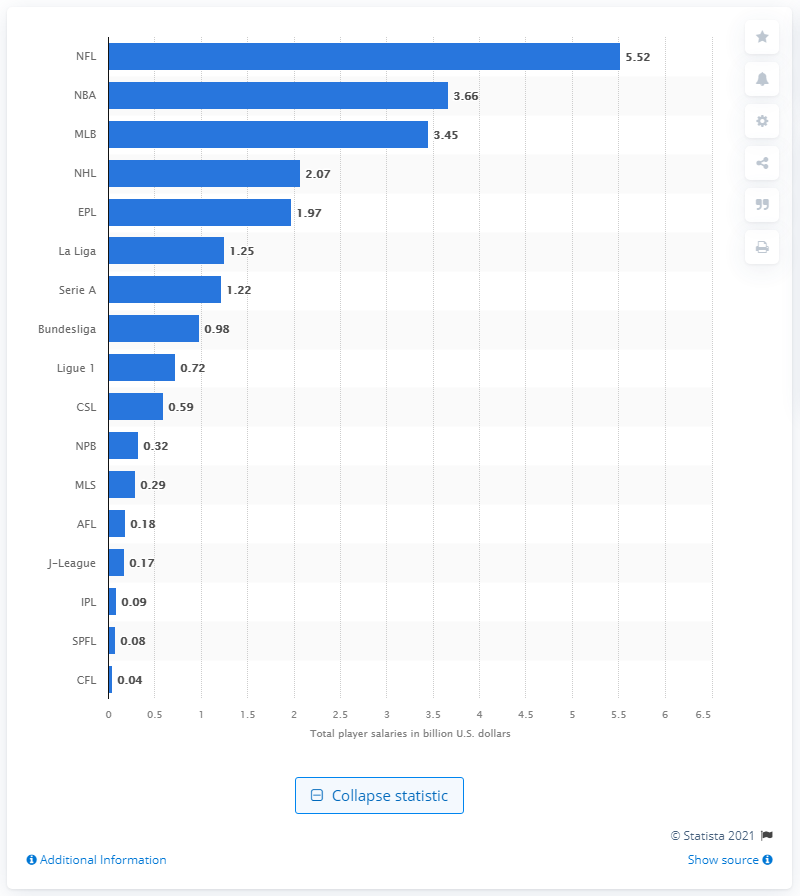Mention a couple of crucial points in this snapshot. The total salary paid to NFL players for the 2019/20 season was 5.52. 